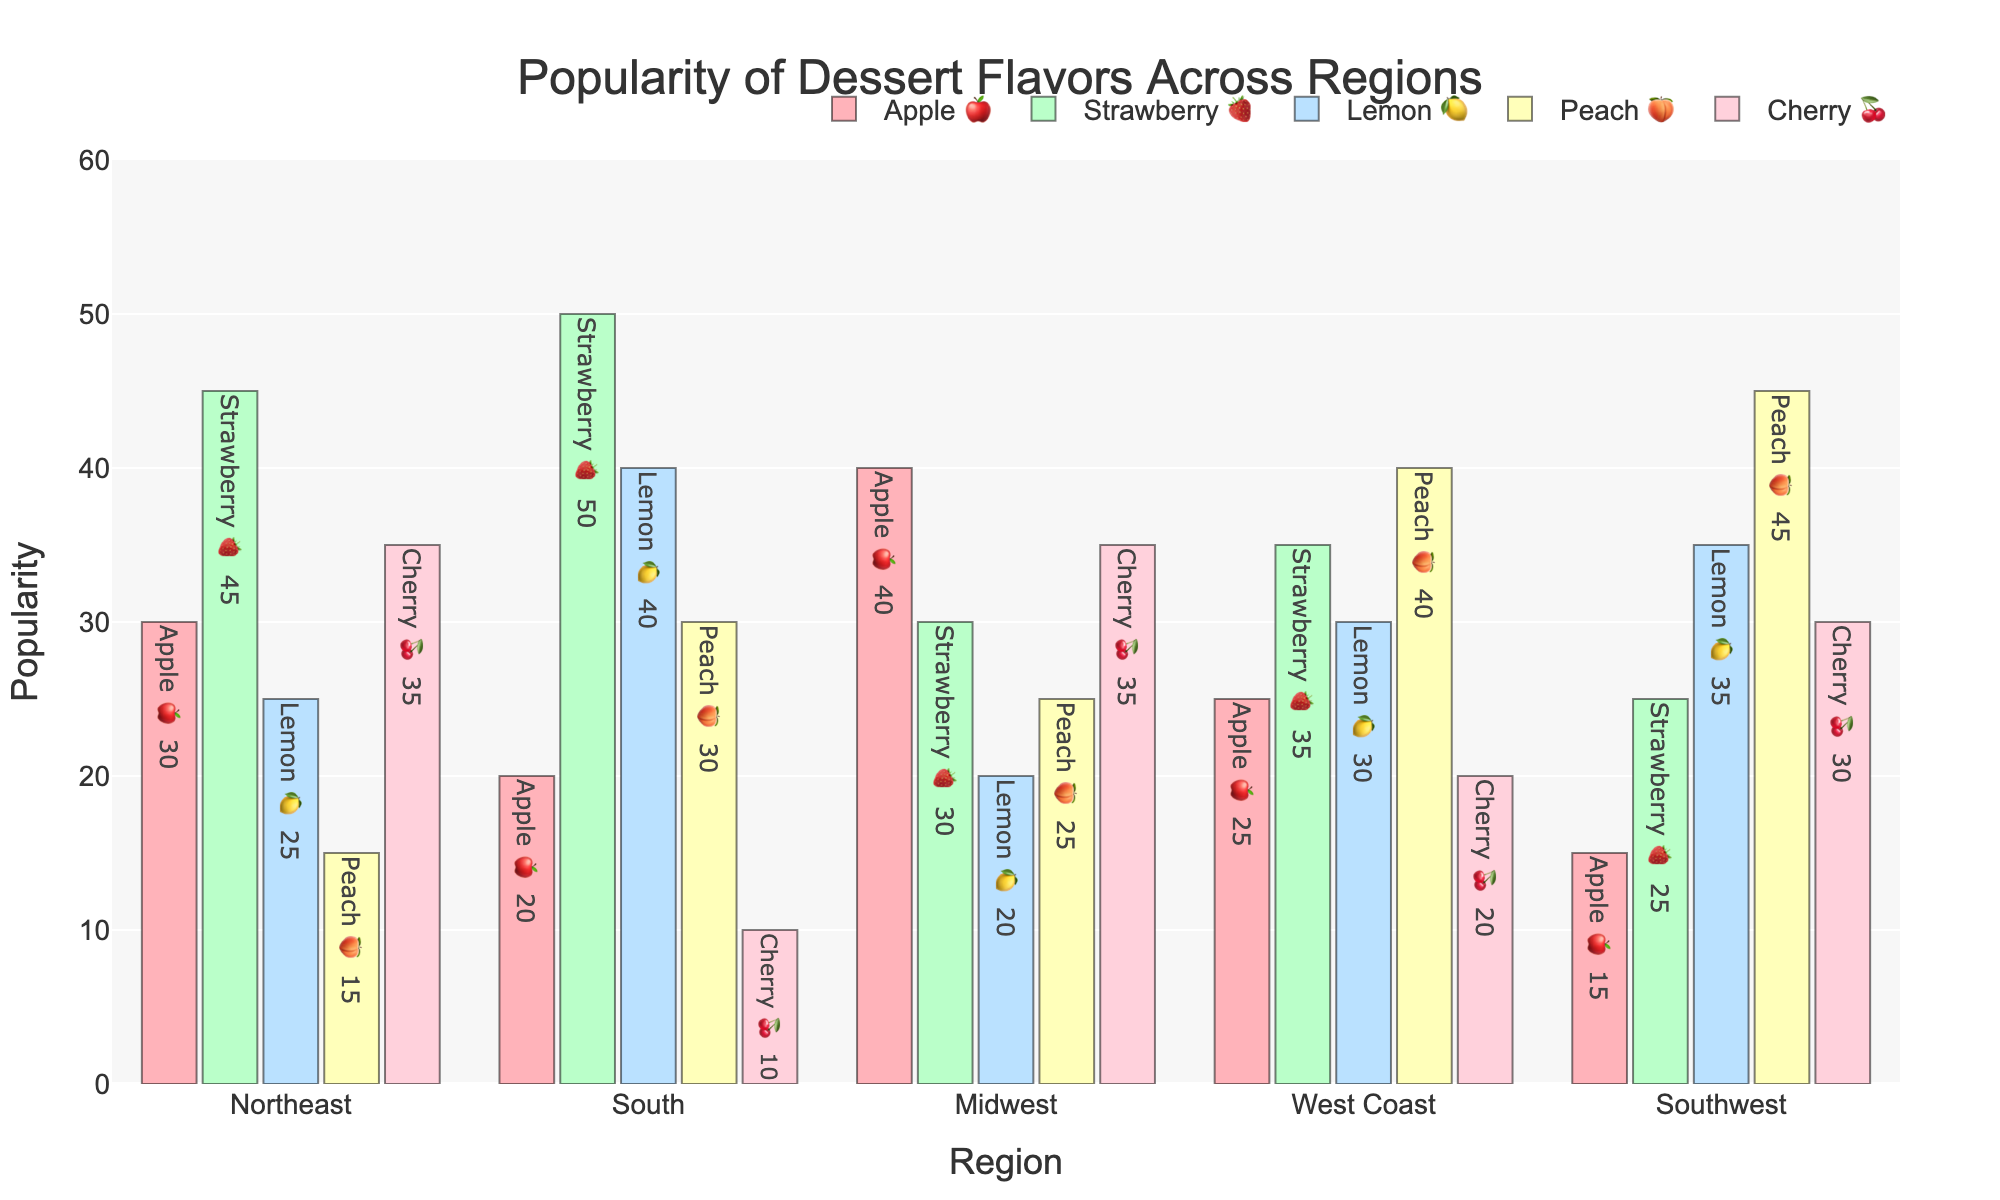What's the most popular dessert flavor in the Northeast region? Based on the chart, the Strawberry 🍓 flavor has the highest value in the Northeast region.
Answer: Strawberry 🍓 Which region shows the highest popularity for Lemon 🍋 desserts? The highest bar for Lemon 🍋 desserts belongs to the South region, indicating the highest popularity for this flavor in the South.
Answer: South What is the total popularity of Cherry 🍒 desserts across all regions combined? Sum the Cherry 🍒 values for all regions: 35 (Northeast) + 10 (South) + 35 (Midwest) + 20 (West Coast) + 30 (Southwest) = 130.
Answer: 130 How does the popularity of Apple 🍎 desserts in the Midwest compare to that in the Southwest? The Midwest shows 40 for Apple 🍎, while the Southwest shows 15. The Midwest is higher by 25 points.
Answer: Midwest is higher by 25 On average, how popular are Peach 🍑 desserts across all regions? Calculate the average by summing Peach 🍑 values and dividing by the number of regions: (15 + 30 + 25 + 40 + 45) / 5 = 31.
Answer: 31 Which region has the least popularity for Strawberry 🍓 desserts, and what is the value? The Southwest region has the lowest value for Strawberry 🍓 desserts, which is 25.
Answer: Southwest, 25 Compare the popularity of Lemon 🍋 and Peach 🍑 flavors in the West Coast region. Which is more popular? In the West Coast region, Lemon 🍋 has a value of 30, while Peach 🍑 has a value of 40. Peach 🍑 is more popular.
Answer: Peach 🍑 What is the difference in popularity between Lemon 🍋 desserts in the Northeast and South regions? The Northeast has 25 for Lemon 🍋, and the South has 40, so the difference is 40 - 25 = 15.
Answer: 15 Across all regions, which flavor has the overall lowest popularity based on total values? Sum the values for each flavor: Apple 🍎 (130), Strawberry 🍓 (185), Lemon 🍋 (150), Peach 🍑 (155), Cherry 🍒 (130). Apple 🍎 and Cherry 🍒 tie for the lowest at 130 each.
Answer: Apple 🍎 and Cherry 🍒 